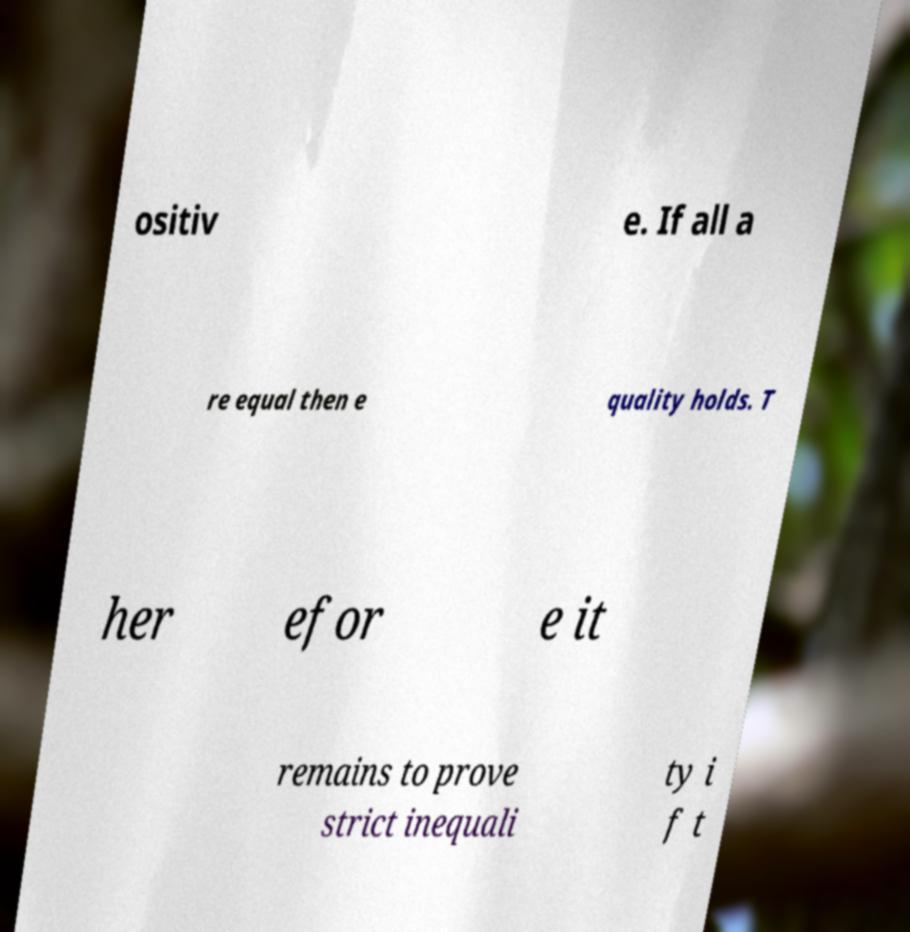Could you assist in decoding the text presented in this image and type it out clearly? ositiv e. If all a re equal then e quality holds. T her efor e it remains to prove strict inequali ty i f t 